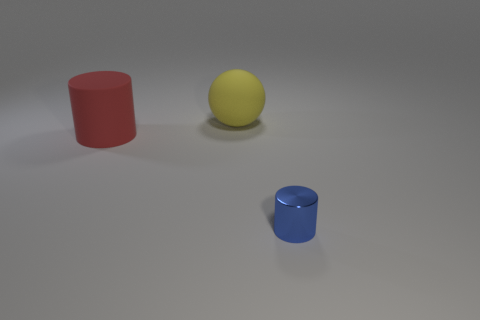Do the metal thing and the big rubber cylinder have the same color?
Give a very brief answer. No. What number of big red matte cylinders are to the right of the small blue cylinder that is to the right of the cylinder behind the small blue metal object?
Offer a very short reply. 0. Are there more balls than small brown metallic cylinders?
Provide a succinct answer. Yes. What number of large purple rubber cylinders are there?
Your answer should be compact. 0. What is the shape of the thing in front of the large matte object that is left of the big matte object right of the big cylinder?
Provide a succinct answer. Cylinder. Are there fewer large red matte things on the right side of the large red cylinder than balls that are to the right of the tiny cylinder?
Offer a terse response. No. Does the rubber thing in front of the big yellow rubber object have the same shape as the object to the right of the large rubber sphere?
Offer a very short reply. Yes. There is a thing that is in front of the large matte object in front of the yellow thing; what is its shape?
Provide a short and direct response. Cylinder. Are there any big red cylinders made of the same material as the large yellow thing?
Ensure brevity in your answer.  Yes. There is a cylinder that is behind the small thing; what is its material?
Provide a short and direct response. Rubber. 